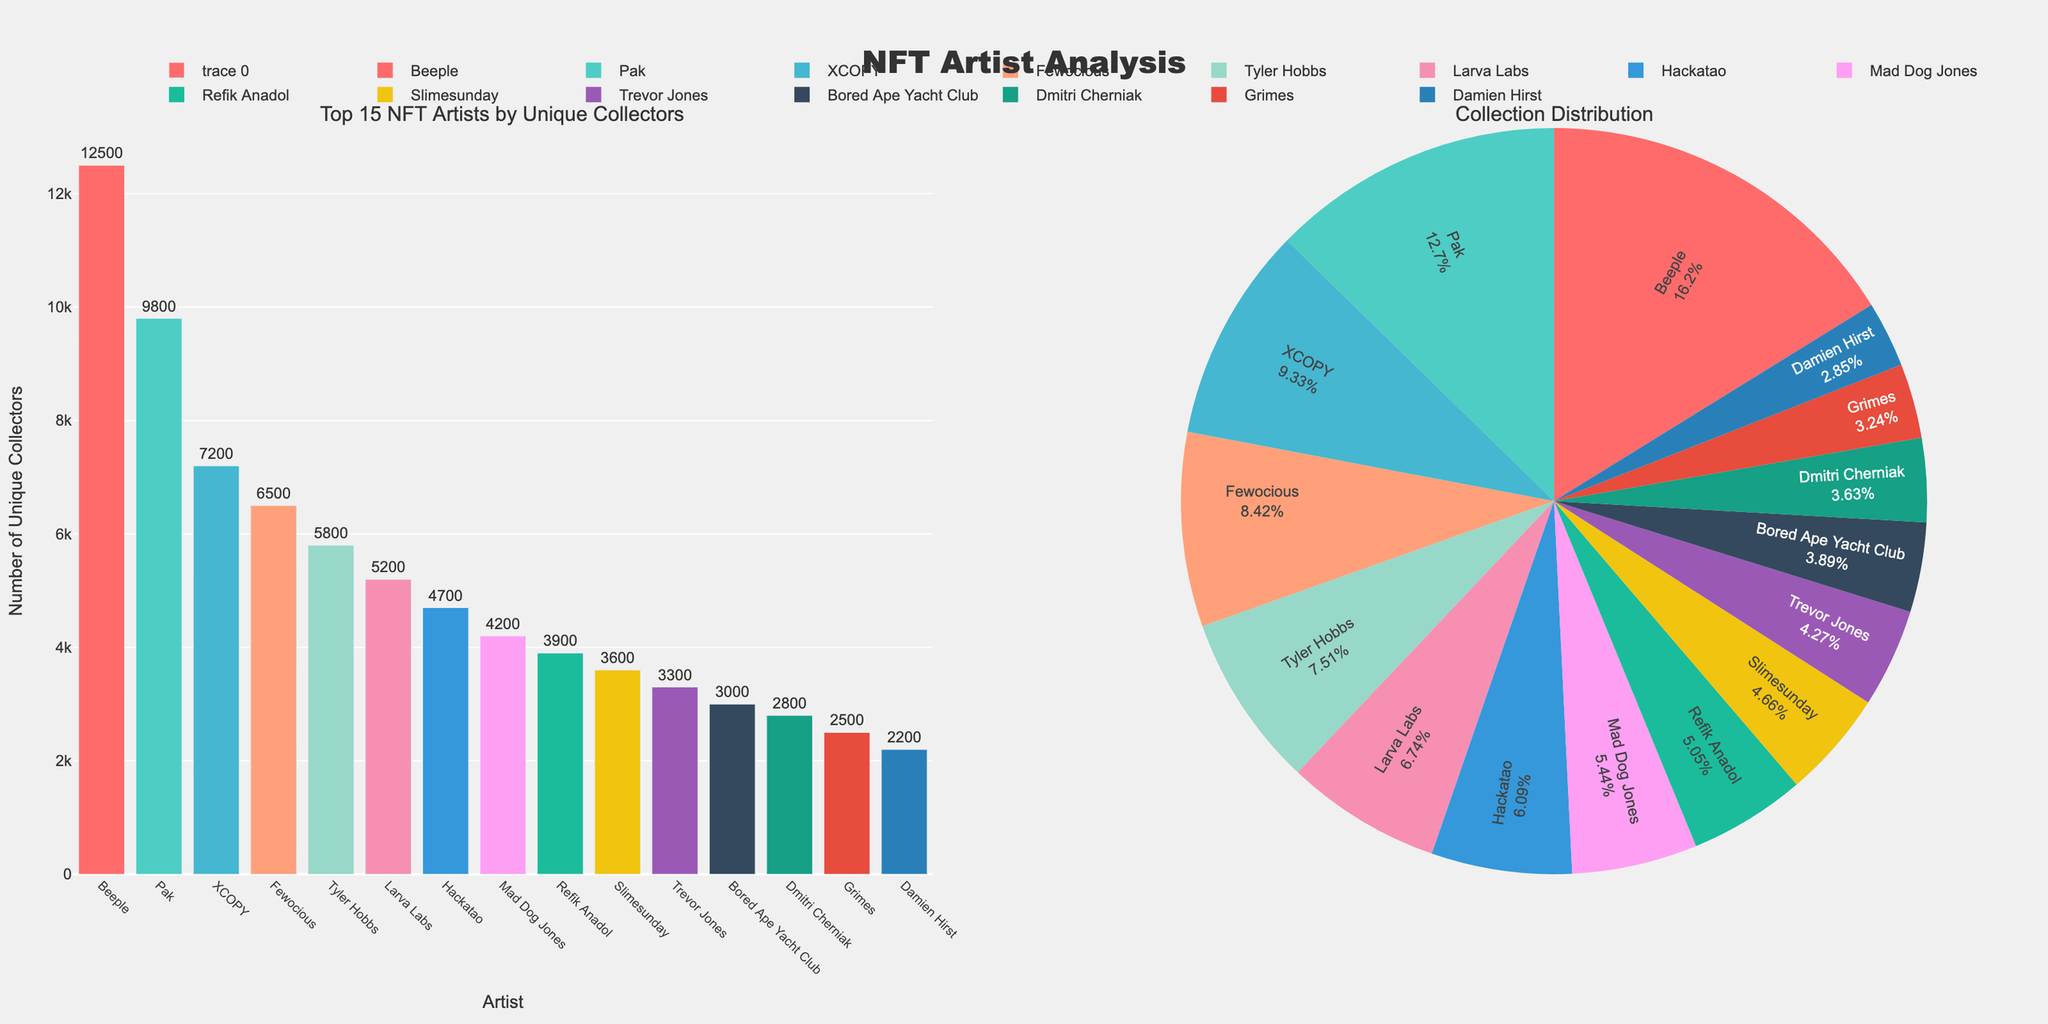What's the title of the figure? The title is displayed at the top of the figure. It says "NFT Artist Analysis".
Answer: NFT Artist Analysis Which artist has the highest number of unique collectors? Look at the bar chart or the pie chart. The bar for Beeple is the tallest, and the pie chart section for Beeple is the largest. Beeple has the highest number of unique collectors.
Answer: Beeple How many artists have more than 5000 unique collectors? Count the number of artists in the bar chart whose bars extend above the 5000 value on the y-axis. There are 6 such artists: Beeple, Pak, XCOPY, Fewocious, Tyler Hobbs, Larva Labs.
Answer: 6 Which collection corresponds to the artist with the lowest number of unique collectors? Look for the artist with the shortest bar in the bar chart, which is Damien Hirst. According to the hovertext, Damien Hirst's collection is "The Currency".
Answer: The Currency What is the total number of unique collectors for all artists combined? Add up the values for each artist from the bar chart. The sum is 12500 + 9800 + 7200 + 6500 + 5800 + 5200 + 4700 + 4200 + 3900 + 3600 + 3300 + 3000 + 2800 + 2500 + 2200 = 83000.
Answer: 83000 Compare the number of unique collectors for Pak and XCOPY. Who has more, and by how much? From the bar chart, Pak has 9800 unique collectors, and XCOPY has 7200 unique collectors. The difference is 9800 - 7200 = 2600. Therefore, Pak has 2600 more unique collectors than XCOPY.
Answer: Pak, by 2600 What percentage of the total unique collectors does Beeple have? Beeple has 12500 unique collectors out of a total of 83000. The percentage is (12500 / 83000) * 100 ≈ 15.06%.
Answer: 15.06% Which color is used to represent Trevor Jones in the bar chart? Identify Trevor Jones in the x-axis of the bar chart. The bar for Trevor Jones is colored purple (#9B59B6).
Answer: Purple Is the number of unique collectors for Bored Ape Yacht Club (BAYC) greater than the number for Grimes? Bored Ape Yacht Club has 3000 unique collectors, and Grimes has 2500 unique collectors. 3000 is greater than 2500.
Answer: Yes What is the average number of unique collectors among the artists except Beeple? Exclude Beeple's 12500 collectors and sum up the remaining: 9800 + 7200 + 6500 + 5800 + 5200 + 4700 + 4200 + 3900 + 3600 + 3300 + 3000 + 2800 + 2500 + 2200 = 70500. There are 14 artists excluding Beeple. The average is 70500 / 14 ≈ 5035.71.
Answer: 5035.71 